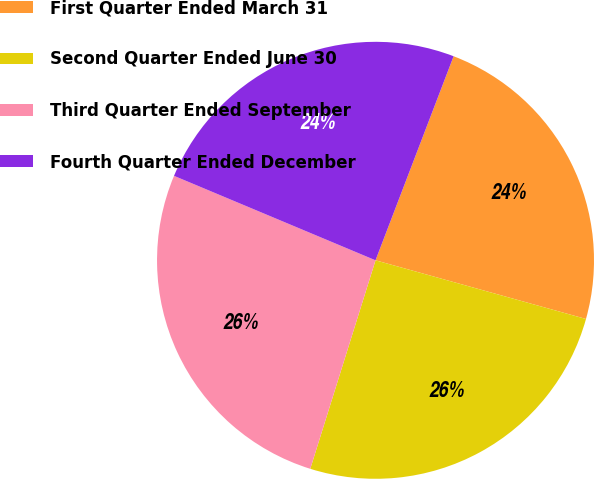Convert chart. <chart><loc_0><loc_0><loc_500><loc_500><pie_chart><fcel>First Quarter Ended March 31<fcel>Second Quarter Ended June 30<fcel>Third Quarter Ended September<fcel>Fourth Quarter Ended December<nl><fcel>23.51%<fcel>25.5%<fcel>26.49%<fcel>24.5%<nl></chart> 